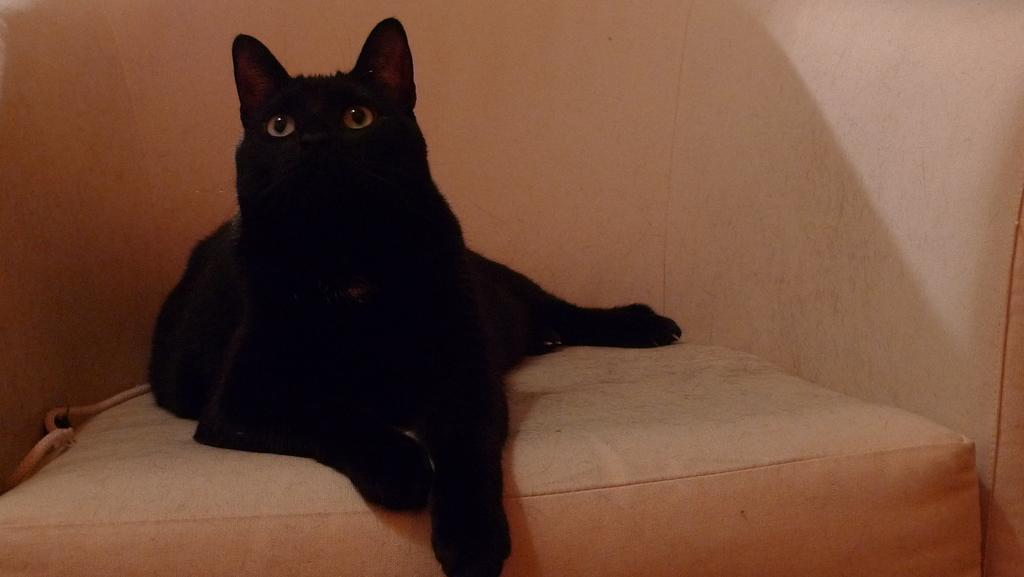What type of animal is in the image? There is a black color cat in the image. Where is the cat located? The cat is on a couch. What type of government is depicted in the image? There is no depiction of a government in the image; it features a black color cat on a couch. How many rods can be seen in the image? There are no rods present in the image. 